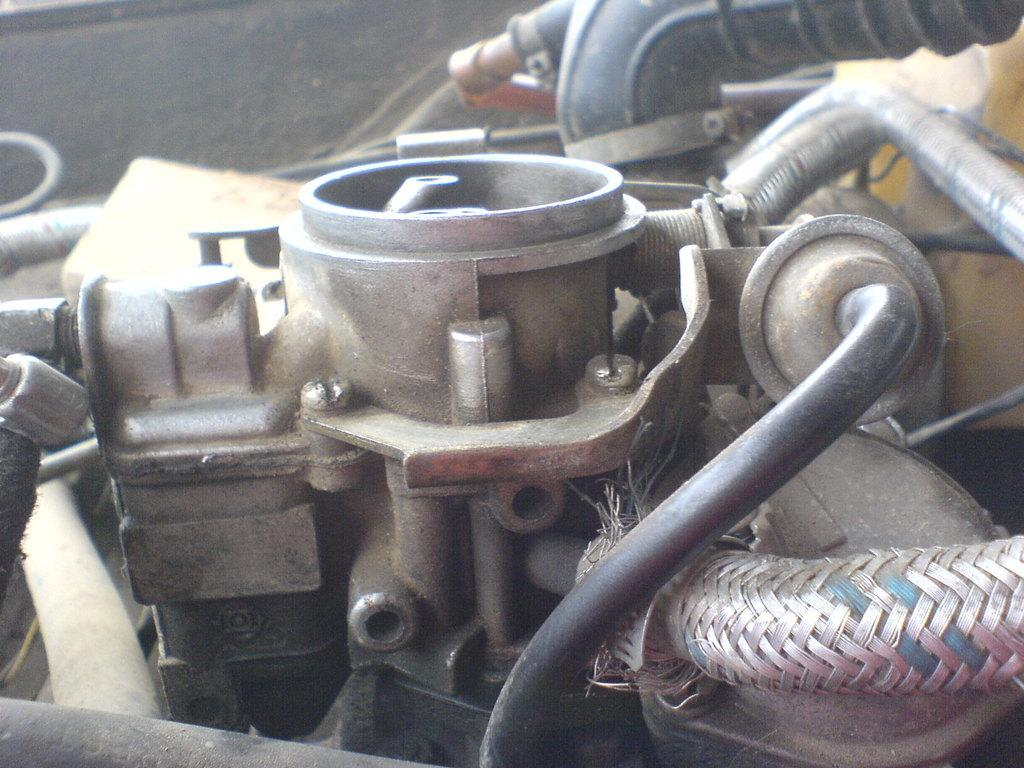What type of materials can be seen in the image? There are metals in the image. What structures are present in the image? There are pipes in the image. What type of quilt is being used to cover the pipes in the image? There is no quilt present in the image; it features metals and pipes. How many pieces of pie can be seen on the pipes in the image? There are no pies present in the image; it only features metals and pipes. 